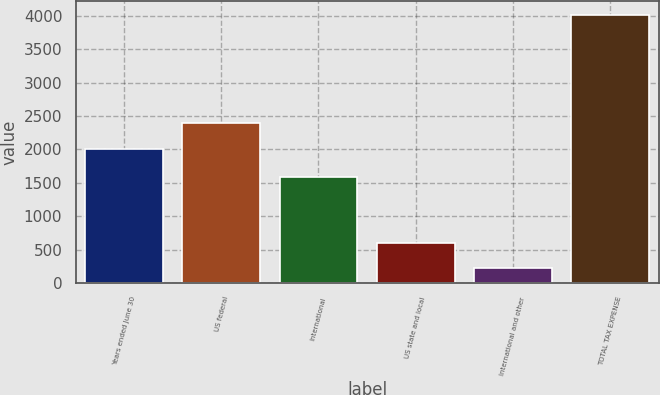<chart> <loc_0><loc_0><loc_500><loc_500><bar_chart><fcel>Years ended June 30<fcel>US federal<fcel>International<fcel>US state and local<fcel>International and other<fcel>TOTAL TAX EXPENSE<nl><fcel>2010<fcel>2390<fcel>1581<fcel>597<fcel>217<fcel>4017<nl></chart> 